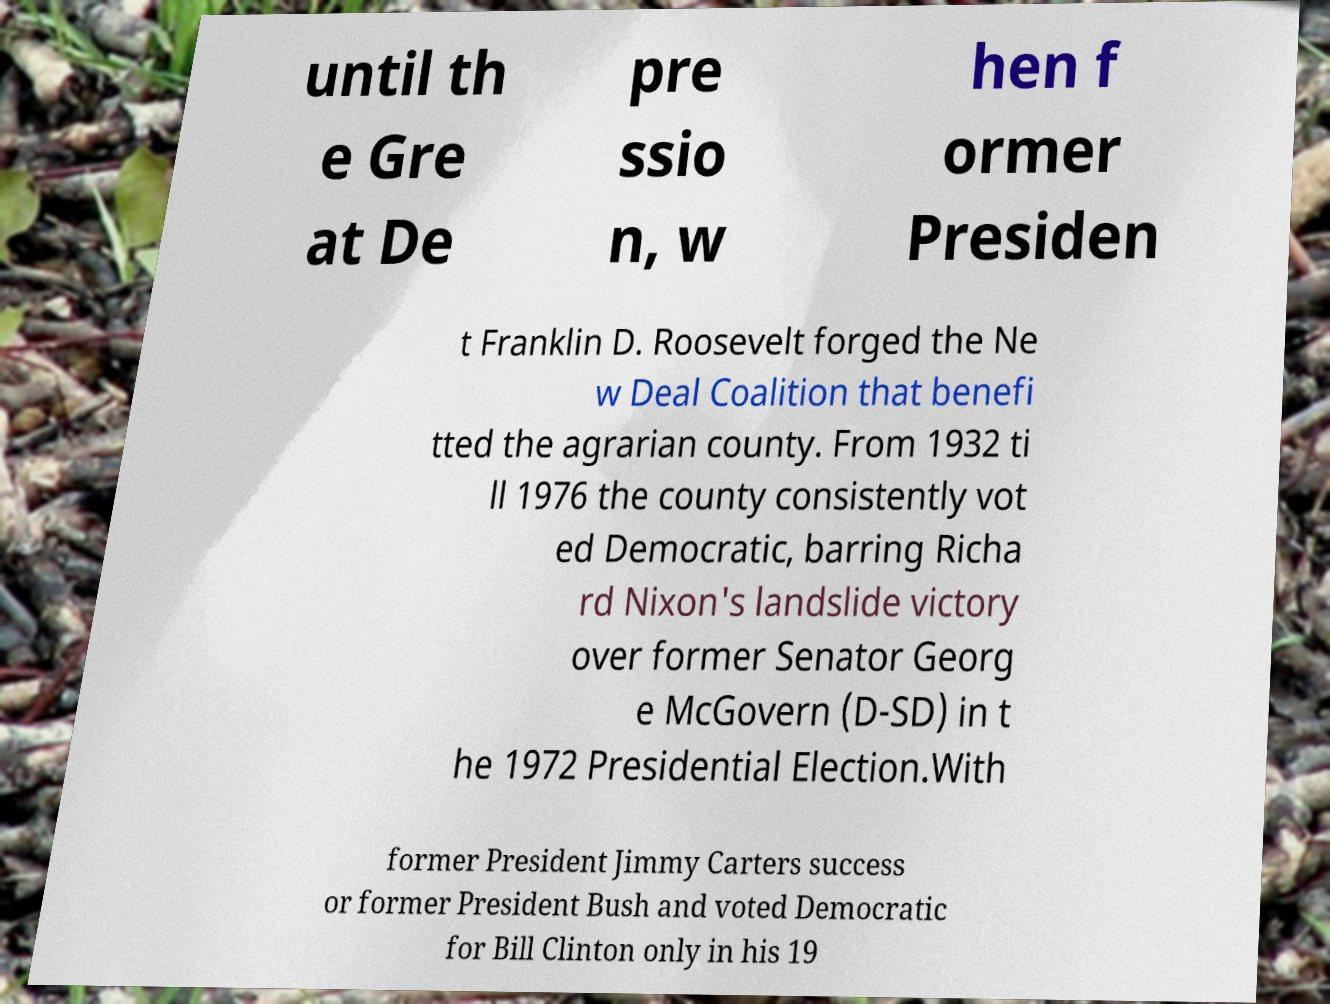Could you assist in decoding the text presented in this image and type it out clearly? until th e Gre at De pre ssio n, w hen f ormer Presiden t Franklin D. Roosevelt forged the Ne w Deal Coalition that benefi tted the agrarian county. From 1932 ti ll 1976 the county consistently vot ed Democratic, barring Richa rd Nixon's landslide victory over former Senator Georg e McGovern (D-SD) in t he 1972 Presidential Election.With former President Jimmy Carters success or former President Bush and voted Democratic for Bill Clinton only in his 19 